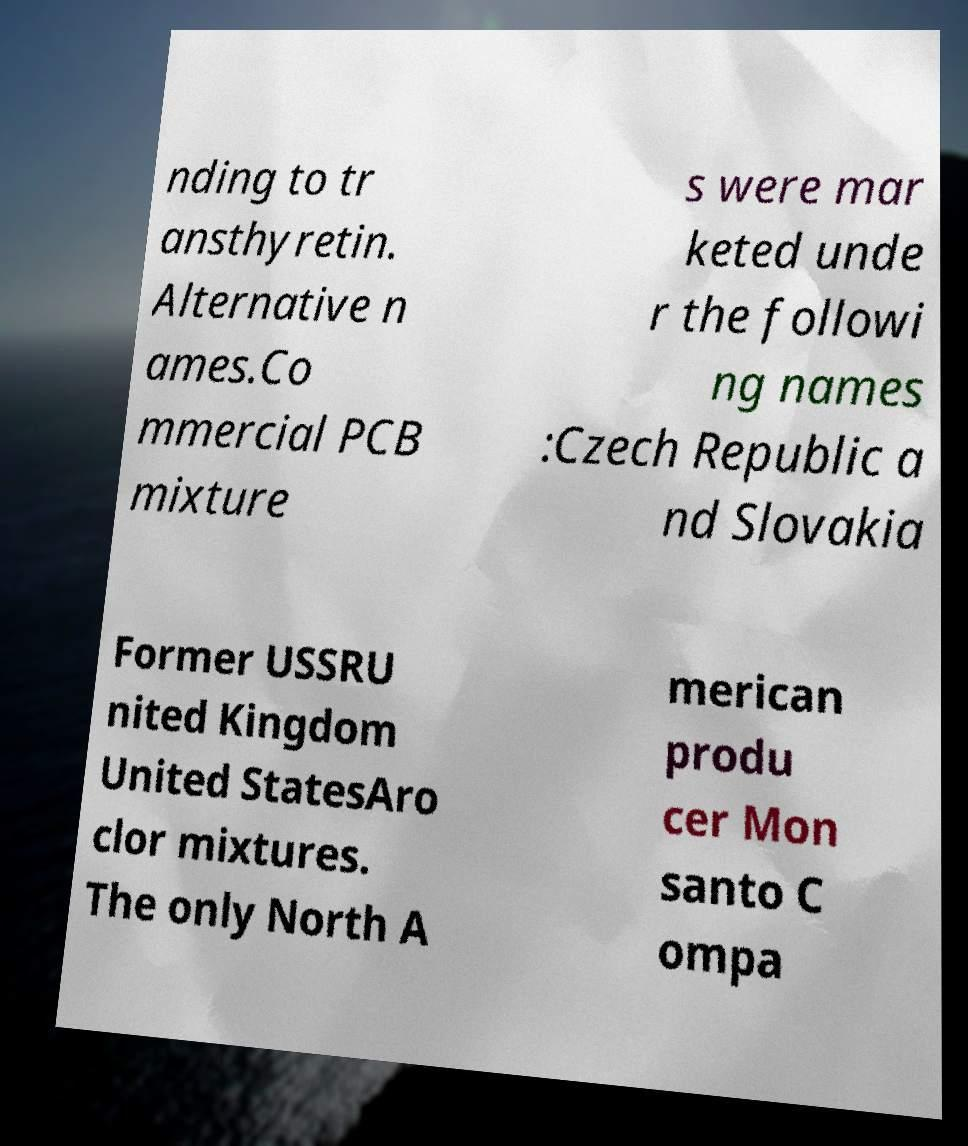Could you assist in decoding the text presented in this image and type it out clearly? nding to tr ansthyretin. Alternative n ames.Co mmercial PCB mixture s were mar keted unde r the followi ng names :Czech Republic a nd Slovakia Former USSRU nited Kingdom United StatesAro clor mixtures. The only North A merican produ cer Mon santo C ompa 